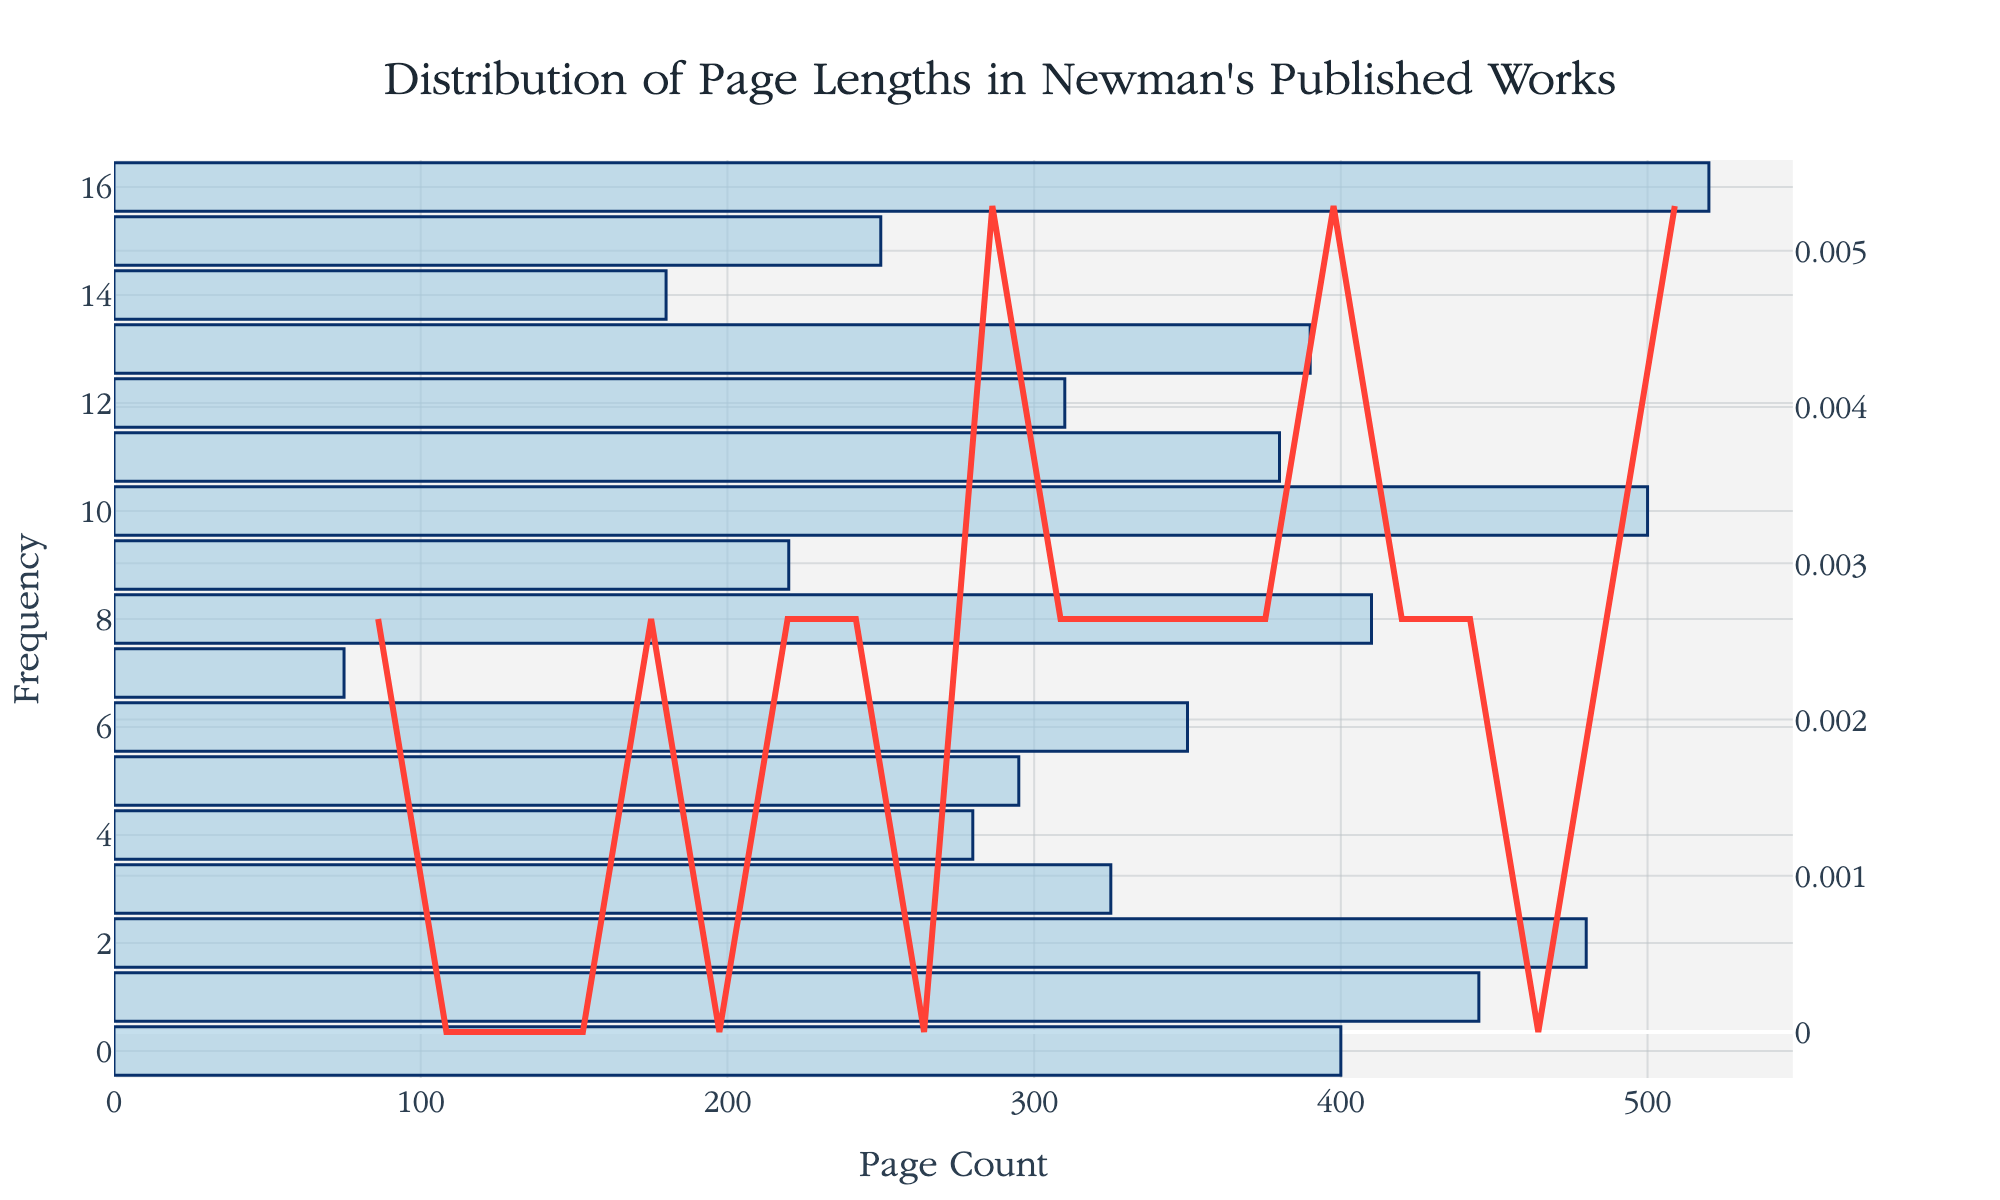What is the title of the figure? The figure title is typically found at the top and is designed to offer a brief description of the data being displayed. In this case, it indicates what is being measured: "Distribution of Page Lengths in Newman's Published Works".
Answer: Distribution of Page Lengths in Newman's Published Works What does the x-axis represent in the histogram? The x-axis is labeled to indicate what is being measured horizontally across the chart. Here, it shows "Page Count", meaning the number of pages in each of Newman's works.
Answer: Page Count How many bars are present in the histogram? The number of bars can be counted manually. These bars represent the frequency distribution of the page counts.
Answer: 17 What is the highest point on the density estimation curve? By observing the KDE (density) curve, we can identify the peak point. This peak represents the highest density of page counts in the figure. It's found around the middle of the distribution.
Answer: Approximately 350 Which work has the highest page count according to the figure? By cross-referencing the individual page counts with the works in the table, we see that the tallest bar on the histogram corresponds to "Letters and Diaries" with 520 pages.
Answer: Letters and Diaries What is the range of the page counts? The range is the difference between the maximum and minimum page counts. The minimum is associated with "The Dream of Gerontius" at 75 pages and the maximum with "Letters and Diaries" at 520 pages.
Answer: 445 What’s the median page count based on the histogram? The median is the middle value when the page counts are sorted in ascending order. For Newman’s works, when sorted, the median is the middle value, given there's an odd number of works.
Answer: 350 Which work corresponds to the smallest bar in the histogram? The smallest bar in the histogram represents the work with the fewest number of pages. Based on the figure, it corresponds to "The Dream of Gerontius" with 75 pages.
Answer: The Dream of Gerontius How does the density curve help in understanding the page count distribution? The density curve provides a smoothed view of the data distribution, showing where the concentration of page counts is higher, making it easier to identify central tendencies and spread.
Answer: Smoother understanding of distribution How many works have page counts above the median value? The median page count is 350. By counting the works with page counts above this value, we can find those that exceed the median. These are "An Essay on the Development of Christian Doctrine," "The Idea of a University," "An Essay in Aid of a Grammar of Assent," "The Arians of the Fourth Century," "Apologia Pro Vita Sua," and "Letters and Diaries."
Answer: 6 